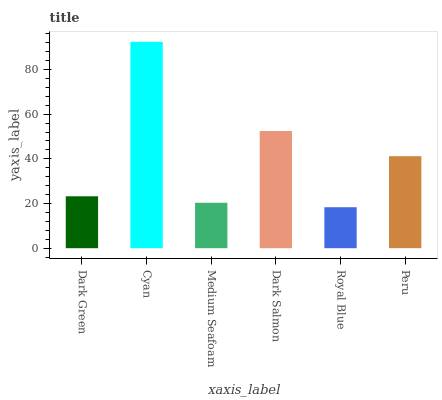Is Medium Seafoam the minimum?
Answer yes or no. No. Is Medium Seafoam the maximum?
Answer yes or no. No. Is Cyan greater than Medium Seafoam?
Answer yes or no. Yes. Is Medium Seafoam less than Cyan?
Answer yes or no. Yes. Is Medium Seafoam greater than Cyan?
Answer yes or no. No. Is Cyan less than Medium Seafoam?
Answer yes or no. No. Is Peru the high median?
Answer yes or no. Yes. Is Dark Green the low median?
Answer yes or no. Yes. Is Dark Salmon the high median?
Answer yes or no. No. Is Cyan the low median?
Answer yes or no. No. 